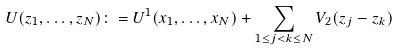Convert formula to latex. <formula><loc_0><loc_0><loc_500><loc_500>U ( z _ { 1 } , \dots , z _ { N } ) \colon = U ^ { 1 } ( x _ { 1 } , \dots , x _ { N } ) + \sum _ { 1 \leq j < k \leq N } V _ { 2 } ( z _ { j } - z _ { k } )</formula> 